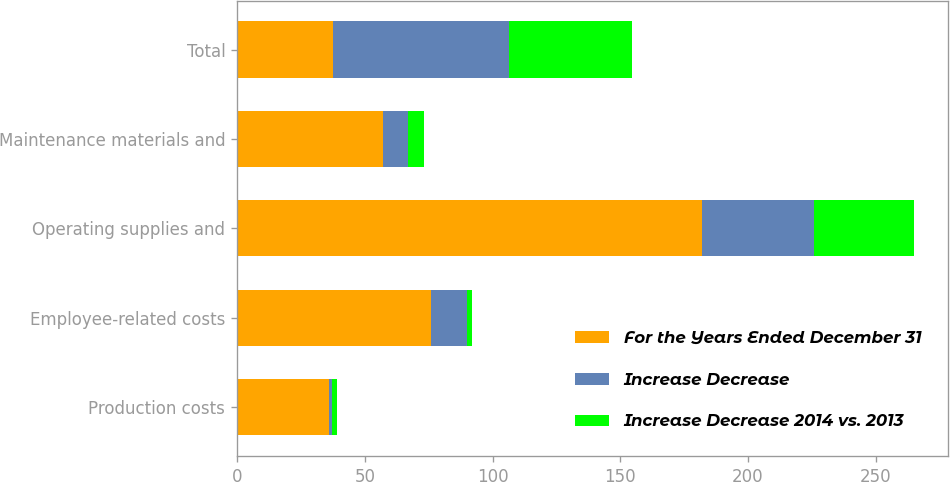Convert chart. <chart><loc_0><loc_0><loc_500><loc_500><stacked_bar_chart><ecel><fcel>Production costs<fcel>Employee-related costs<fcel>Operating supplies and<fcel>Maintenance materials and<fcel>Total<nl><fcel>For the Years Ended December 31<fcel>36<fcel>76<fcel>182<fcel>57<fcel>37.5<nl><fcel>Increase Decrease<fcel>1<fcel>14<fcel>44<fcel>10<fcel>69<nl><fcel>Increase Decrease 2014 vs. 2013<fcel>2<fcel>2<fcel>39<fcel>6<fcel>48<nl></chart> 